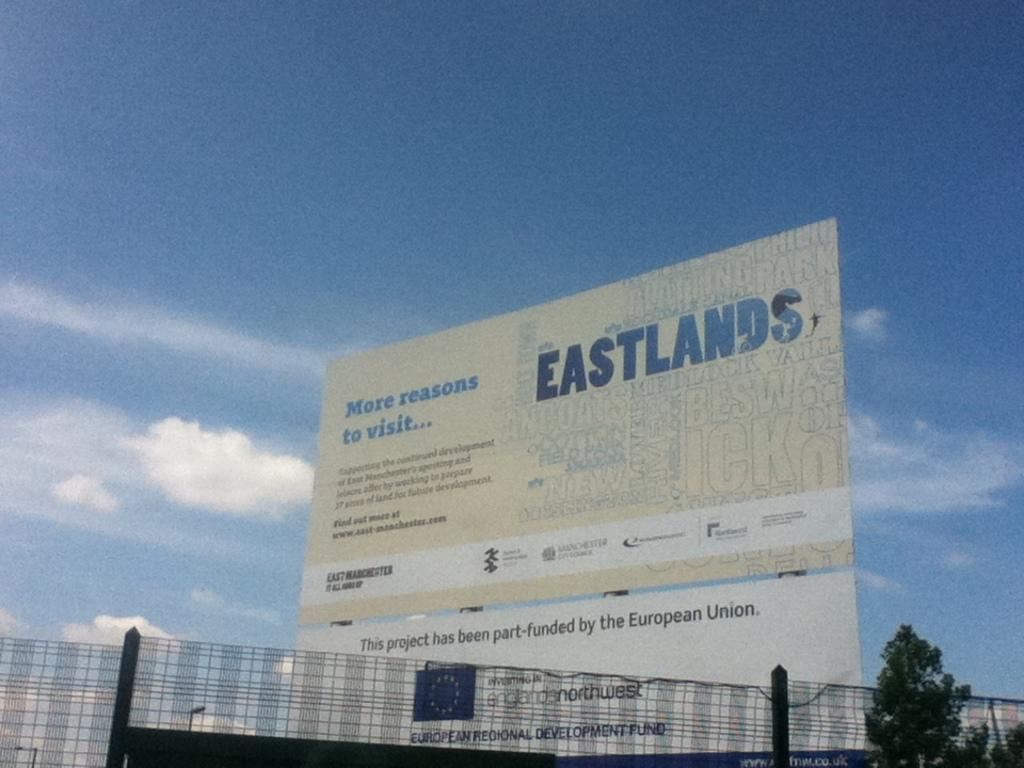<image>
Describe the image concisely. Eastlands banner showing more reasons to wait with an e logo. 